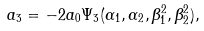<formula> <loc_0><loc_0><loc_500><loc_500>a _ { 3 } = - 2 a _ { 0 } \Psi _ { 3 } ( \alpha _ { 1 } , \alpha _ { 2 } , \beta _ { 1 } ^ { 2 } , \beta _ { 2 } ^ { 2 } ) ,</formula> 